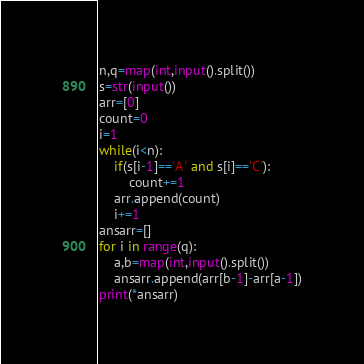<code> <loc_0><loc_0><loc_500><loc_500><_Python_>n,q=map(int,input().split())
s=str(input())
arr=[0]
count=0
i=1
while(i<n):
	if(s[i-1]=='A' and s[i]=='C'):
		count+=1
	arr.append(count)
	i+=1
ansarr=[]
for i in range(q):
	a,b=map(int,input().split())
	ansarr.append(arr[b-1]-arr[a-1])
print(*ansarr)

</code> 